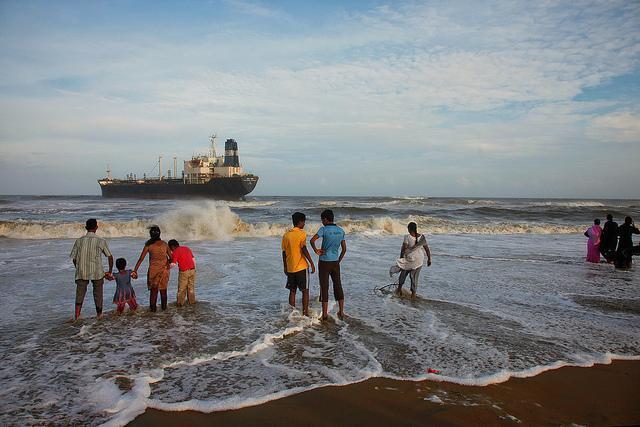How many cruise ships are there?
Give a very brief answer. 1. How many people are in the water?
Give a very brief answer. 10. How many people are in the photo?
Give a very brief answer. 3. 